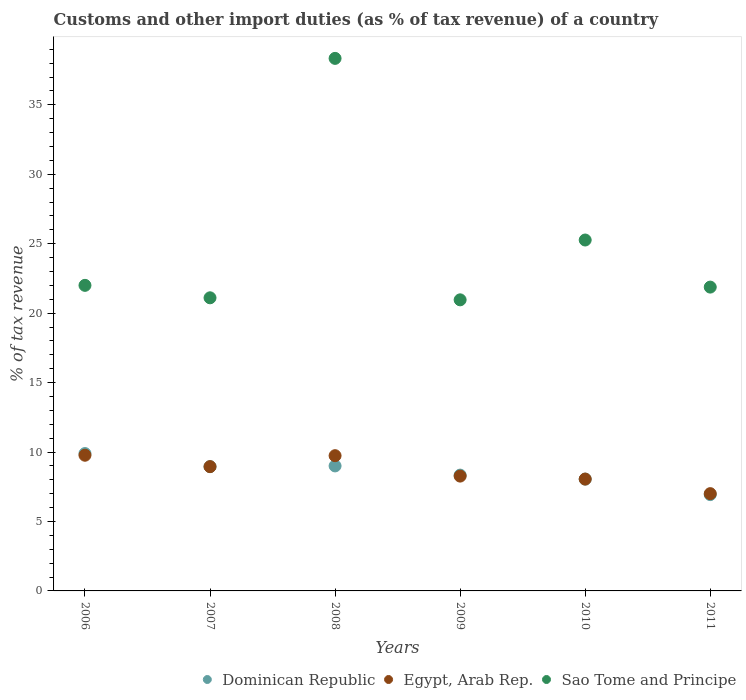Is the number of dotlines equal to the number of legend labels?
Provide a succinct answer. Yes. What is the percentage of tax revenue from customs in Sao Tome and Principe in 2010?
Provide a short and direct response. 25.27. Across all years, what is the maximum percentage of tax revenue from customs in Egypt, Arab Rep.?
Ensure brevity in your answer.  9.77. Across all years, what is the minimum percentage of tax revenue from customs in Sao Tome and Principe?
Your response must be concise. 20.96. In which year was the percentage of tax revenue from customs in Dominican Republic maximum?
Give a very brief answer. 2006. In which year was the percentage of tax revenue from customs in Dominican Republic minimum?
Ensure brevity in your answer.  2011. What is the total percentage of tax revenue from customs in Dominican Republic in the graph?
Keep it short and to the point. 51.17. What is the difference between the percentage of tax revenue from customs in Dominican Republic in 2006 and that in 2011?
Provide a succinct answer. 2.96. What is the difference between the percentage of tax revenue from customs in Egypt, Arab Rep. in 2008 and the percentage of tax revenue from customs in Dominican Republic in 2009?
Give a very brief answer. 1.4. What is the average percentage of tax revenue from customs in Sao Tome and Principe per year?
Your answer should be compact. 24.93. In the year 2009, what is the difference between the percentage of tax revenue from customs in Dominican Republic and percentage of tax revenue from customs in Egypt, Arab Rep.?
Offer a very short reply. 0.07. In how many years, is the percentage of tax revenue from customs in Egypt, Arab Rep. greater than 14 %?
Ensure brevity in your answer.  0. What is the ratio of the percentage of tax revenue from customs in Dominican Republic in 2009 to that in 2011?
Your response must be concise. 1.2. Is the percentage of tax revenue from customs in Dominican Republic in 2007 less than that in 2009?
Offer a very short reply. No. What is the difference between the highest and the second highest percentage of tax revenue from customs in Egypt, Arab Rep.?
Your response must be concise. 0.03. What is the difference between the highest and the lowest percentage of tax revenue from customs in Dominican Republic?
Provide a short and direct response. 2.96. In how many years, is the percentage of tax revenue from customs in Egypt, Arab Rep. greater than the average percentage of tax revenue from customs in Egypt, Arab Rep. taken over all years?
Your response must be concise. 3. Is the sum of the percentage of tax revenue from customs in Sao Tome and Principe in 2006 and 2007 greater than the maximum percentage of tax revenue from customs in Egypt, Arab Rep. across all years?
Give a very brief answer. Yes. Does the percentage of tax revenue from customs in Egypt, Arab Rep. monotonically increase over the years?
Offer a terse response. No. Is the percentage of tax revenue from customs in Sao Tome and Principe strictly greater than the percentage of tax revenue from customs in Dominican Republic over the years?
Provide a short and direct response. Yes. Is the percentage of tax revenue from customs in Sao Tome and Principe strictly less than the percentage of tax revenue from customs in Egypt, Arab Rep. over the years?
Make the answer very short. No. How many dotlines are there?
Provide a short and direct response. 3. How many years are there in the graph?
Provide a succinct answer. 6. Are the values on the major ticks of Y-axis written in scientific E-notation?
Your answer should be compact. No. Where does the legend appear in the graph?
Keep it short and to the point. Bottom right. What is the title of the graph?
Your answer should be very brief. Customs and other import duties (as % of tax revenue) of a country. Does "Cabo Verde" appear as one of the legend labels in the graph?
Offer a very short reply. No. What is the label or title of the X-axis?
Ensure brevity in your answer.  Years. What is the label or title of the Y-axis?
Offer a terse response. % of tax revenue. What is the % of tax revenue of Dominican Republic in 2006?
Provide a short and direct response. 9.89. What is the % of tax revenue of Egypt, Arab Rep. in 2006?
Your response must be concise. 9.77. What is the % of tax revenue in Sao Tome and Principe in 2006?
Provide a succinct answer. 22. What is the % of tax revenue of Dominican Republic in 2007?
Offer a terse response. 8.95. What is the % of tax revenue of Egypt, Arab Rep. in 2007?
Your response must be concise. 8.95. What is the % of tax revenue of Sao Tome and Principe in 2007?
Keep it short and to the point. 21.11. What is the % of tax revenue of Dominican Republic in 2008?
Ensure brevity in your answer.  9. What is the % of tax revenue in Egypt, Arab Rep. in 2008?
Provide a short and direct response. 9.74. What is the % of tax revenue in Sao Tome and Principe in 2008?
Provide a succinct answer. 38.35. What is the % of tax revenue in Dominican Republic in 2009?
Ensure brevity in your answer.  8.34. What is the % of tax revenue in Egypt, Arab Rep. in 2009?
Offer a terse response. 8.27. What is the % of tax revenue in Sao Tome and Principe in 2009?
Your answer should be compact. 20.96. What is the % of tax revenue in Dominican Republic in 2010?
Your answer should be compact. 8.05. What is the % of tax revenue in Egypt, Arab Rep. in 2010?
Offer a terse response. 8.05. What is the % of tax revenue in Sao Tome and Principe in 2010?
Your response must be concise. 25.27. What is the % of tax revenue in Dominican Republic in 2011?
Keep it short and to the point. 6.94. What is the % of tax revenue in Egypt, Arab Rep. in 2011?
Your answer should be very brief. 7.01. What is the % of tax revenue of Sao Tome and Principe in 2011?
Your response must be concise. 21.88. Across all years, what is the maximum % of tax revenue in Dominican Republic?
Ensure brevity in your answer.  9.89. Across all years, what is the maximum % of tax revenue in Egypt, Arab Rep.?
Your response must be concise. 9.77. Across all years, what is the maximum % of tax revenue in Sao Tome and Principe?
Your answer should be very brief. 38.35. Across all years, what is the minimum % of tax revenue of Dominican Republic?
Your answer should be very brief. 6.94. Across all years, what is the minimum % of tax revenue in Egypt, Arab Rep.?
Provide a short and direct response. 7.01. Across all years, what is the minimum % of tax revenue of Sao Tome and Principe?
Offer a very short reply. 20.96. What is the total % of tax revenue of Dominican Republic in the graph?
Make the answer very short. 51.17. What is the total % of tax revenue in Egypt, Arab Rep. in the graph?
Give a very brief answer. 51.79. What is the total % of tax revenue of Sao Tome and Principe in the graph?
Provide a succinct answer. 149.57. What is the difference between the % of tax revenue of Dominican Republic in 2006 and that in 2007?
Keep it short and to the point. 0.94. What is the difference between the % of tax revenue in Egypt, Arab Rep. in 2006 and that in 2007?
Your answer should be compact. 0.82. What is the difference between the % of tax revenue in Sao Tome and Principe in 2006 and that in 2007?
Your answer should be compact. 0.9. What is the difference between the % of tax revenue in Dominican Republic in 2006 and that in 2008?
Keep it short and to the point. 0.89. What is the difference between the % of tax revenue in Egypt, Arab Rep. in 2006 and that in 2008?
Your answer should be very brief. 0.03. What is the difference between the % of tax revenue in Sao Tome and Principe in 2006 and that in 2008?
Make the answer very short. -16.34. What is the difference between the % of tax revenue in Dominican Republic in 2006 and that in 2009?
Your answer should be very brief. 1.55. What is the difference between the % of tax revenue of Egypt, Arab Rep. in 2006 and that in 2009?
Provide a succinct answer. 1.5. What is the difference between the % of tax revenue in Sao Tome and Principe in 2006 and that in 2009?
Offer a very short reply. 1.04. What is the difference between the % of tax revenue of Dominican Republic in 2006 and that in 2010?
Give a very brief answer. 1.84. What is the difference between the % of tax revenue of Egypt, Arab Rep. in 2006 and that in 2010?
Keep it short and to the point. 1.72. What is the difference between the % of tax revenue of Sao Tome and Principe in 2006 and that in 2010?
Your answer should be very brief. -3.26. What is the difference between the % of tax revenue of Dominican Republic in 2006 and that in 2011?
Give a very brief answer. 2.96. What is the difference between the % of tax revenue of Egypt, Arab Rep. in 2006 and that in 2011?
Offer a very short reply. 2.77. What is the difference between the % of tax revenue in Sao Tome and Principe in 2006 and that in 2011?
Your answer should be compact. 0.13. What is the difference between the % of tax revenue in Dominican Republic in 2007 and that in 2008?
Provide a succinct answer. -0.05. What is the difference between the % of tax revenue of Egypt, Arab Rep. in 2007 and that in 2008?
Keep it short and to the point. -0.79. What is the difference between the % of tax revenue of Sao Tome and Principe in 2007 and that in 2008?
Keep it short and to the point. -17.24. What is the difference between the % of tax revenue of Dominican Republic in 2007 and that in 2009?
Ensure brevity in your answer.  0.61. What is the difference between the % of tax revenue in Egypt, Arab Rep. in 2007 and that in 2009?
Keep it short and to the point. 0.68. What is the difference between the % of tax revenue in Sao Tome and Principe in 2007 and that in 2009?
Offer a very short reply. 0.15. What is the difference between the % of tax revenue in Dominican Republic in 2007 and that in 2010?
Offer a terse response. 0.9. What is the difference between the % of tax revenue in Egypt, Arab Rep. in 2007 and that in 2010?
Provide a succinct answer. 0.9. What is the difference between the % of tax revenue of Sao Tome and Principe in 2007 and that in 2010?
Provide a short and direct response. -4.16. What is the difference between the % of tax revenue in Dominican Republic in 2007 and that in 2011?
Provide a short and direct response. 2.01. What is the difference between the % of tax revenue in Egypt, Arab Rep. in 2007 and that in 2011?
Your response must be concise. 1.95. What is the difference between the % of tax revenue in Sao Tome and Principe in 2007 and that in 2011?
Offer a very short reply. -0.77. What is the difference between the % of tax revenue in Dominican Republic in 2008 and that in 2009?
Provide a short and direct response. 0.66. What is the difference between the % of tax revenue in Egypt, Arab Rep. in 2008 and that in 2009?
Make the answer very short. 1.47. What is the difference between the % of tax revenue in Sao Tome and Principe in 2008 and that in 2009?
Provide a short and direct response. 17.39. What is the difference between the % of tax revenue in Dominican Republic in 2008 and that in 2010?
Provide a short and direct response. 0.95. What is the difference between the % of tax revenue in Egypt, Arab Rep. in 2008 and that in 2010?
Give a very brief answer. 1.68. What is the difference between the % of tax revenue in Sao Tome and Principe in 2008 and that in 2010?
Offer a very short reply. 13.08. What is the difference between the % of tax revenue in Dominican Republic in 2008 and that in 2011?
Provide a succinct answer. 2.07. What is the difference between the % of tax revenue of Egypt, Arab Rep. in 2008 and that in 2011?
Your answer should be very brief. 2.73. What is the difference between the % of tax revenue of Sao Tome and Principe in 2008 and that in 2011?
Offer a very short reply. 16.47. What is the difference between the % of tax revenue in Dominican Republic in 2009 and that in 2010?
Your response must be concise. 0.29. What is the difference between the % of tax revenue of Egypt, Arab Rep. in 2009 and that in 2010?
Give a very brief answer. 0.21. What is the difference between the % of tax revenue in Sao Tome and Principe in 2009 and that in 2010?
Your response must be concise. -4.31. What is the difference between the % of tax revenue in Dominican Republic in 2009 and that in 2011?
Make the answer very short. 1.4. What is the difference between the % of tax revenue in Egypt, Arab Rep. in 2009 and that in 2011?
Provide a short and direct response. 1.26. What is the difference between the % of tax revenue in Sao Tome and Principe in 2009 and that in 2011?
Offer a very short reply. -0.92. What is the difference between the % of tax revenue in Dominican Republic in 2010 and that in 2011?
Your response must be concise. 1.12. What is the difference between the % of tax revenue in Egypt, Arab Rep. in 2010 and that in 2011?
Ensure brevity in your answer.  1.05. What is the difference between the % of tax revenue of Sao Tome and Principe in 2010 and that in 2011?
Make the answer very short. 3.39. What is the difference between the % of tax revenue of Dominican Republic in 2006 and the % of tax revenue of Egypt, Arab Rep. in 2007?
Offer a terse response. 0.94. What is the difference between the % of tax revenue in Dominican Republic in 2006 and the % of tax revenue in Sao Tome and Principe in 2007?
Provide a succinct answer. -11.22. What is the difference between the % of tax revenue of Egypt, Arab Rep. in 2006 and the % of tax revenue of Sao Tome and Principe in 2007?
Give a very brief answer. -11.34. What is the difference between the % of tax revenue of Dominican Republic in 2006 and the % of tax revenue of Egypt, Arab Rep. in 2008?
Make the answer very short. 0.15. What is the difference between the % of tax revenue in Dominican Republic in 2006 and the % of tax revenue in Sao Tome and Principe in 2008?
Ensure brevity in your answer.  -28.46. What is the difference between the % of tax revenue in Egypt, Arab Rep. in 2006 and the % of tax revenue in Sao Tome and Principe in 2008?
Make the answer very short. -28.58. What is the difference between the % of tax revenue in Dominican Republic in 2006 and the % of tax revenue in Egypt, Arab Rep. in 2009?
Your response must be concise. 1.62. What is the difference between the % of tax revenue of Dominican Republic in 2006 and the % of tax revenue of Sao Tome and Principe in 2009?
Ensure brevity in your answer.  -11.07. What is the difference between the % of tax revenue in Egypt, Arab Rep. in 2006 and the % of tax revenue in Sao Tome and Principe in 2009?
Ensure brevity in your answer.  -11.19. What is the difference between the % of tax revenue of Dominican Republic in 2006 and the % of tax revenue of Egypt, Arab Rep. in 2010?
Make the answer very short. 1.84. What is the difference between the % of tax revenue of Dominican Republic in 2006 and the % of tax revenue of Sao Tome and Principe in 2010?
Provide a succinct answer. -15.38. What is the difference between the % of tax revenue of Egypt, Arab Rep. in 2006 and the % of tax revenue of Sao Tome and Principe in 2010?
Your response must be concise. -15.5. What is the difference between the % of tax revenue in Dominican Republic in 2006 and the % of tax revenue in Egypt, Arab Rep. in 2011?
Offer a very short reply. 2.89. What is the difference between the % of tax revenue in Dominican Republic in 2006 and the % of tax revenue in Sao Tome and Principe in 2011?
Offer a very short reply. -11.99. What is the difference between the % of tax revenue of Egypt, Arab Rep. in 2006 and the % of tax revenue of Sao Tome and Principe in 2011?
Give a very brief answer. -12.11. What is the difference between the % of tax revenue in Dominican Republic in 2007 and the % of tax revenue in Egypt, Arab Rep. in 2008?
Your response must be concise. -0.79. What is the difference between the % of tax revenue of Dominican Republic in 2007 and the % of tax revenue of Sao Tome and Principe in 2008?
Keep it short and to the point. -29.4. What is the difference between the % of tax revenue of Egypt, Arab Rep. in 2007 and the % of tax revenue of Sao Tome and Principe in 2008?
Your answer should be very brief. -29.4. What is the difference between the % of tax revenue in Dominican Republic in 2007 and the % of tax revenue in Egypt, Arab Rep. in 2009?
Your response must be concise. 0.68. What is the difference between the % of tax revenue in Dominican Republic in 2007 and the % of tax revenue in Sao Tome and Principe in 2009?
Offer a very short reply. -12.01. What is the difference between the % of tax revenue in Egypt, Arab Rep. in 2007 and the % of tax revenue in Sao Tome and Principe in 2009?
Make the answer very short. -12.01. What is the difference between the % of tax revenue of Dominican Republic in 2007 and the % of tax revenue of Egypt, Arab Rep. in 2010?
Keep it short and to the point. 0.89. What is the difference between the % of tax revenue in Dominican Republic in 2007 and the % of tax revenue in Sao Tome and Principe in 2010?
Your answer should be very brief. -16.32. What is the difference between the % of tax revenue of Egypt, Arab Rep. in 2007 and the % of tax revenue of Sao Tome and Principe in 2010?
Ensure brevity in your answer.  -16.32. What is the difference between the % of tax revenue in Dominican Republic in 2007 and the % of tax revenue in Egypt, Arab Rep. in 2011?
Give a very brief answer. 1.94. What is the difference between the % of tax revenue of Dominican Republic in 2007 and the % of tax revenue of Sao Tome and Principe in 2011?
Offer a terse response. -12.93. What is the difference between the % of tax revenue in Egypt, Arab Rep. in 2007 and the % of tax revenue in Sao Tome and Principe in 2011?
Your answer should be compact. -12.93. What is the difference between the % of tax revenue of Dominican Republic in 2008 and the % of tax revenue of Egypt, Arab Rep. in 2009?
Ensure brevity in your answer.  0.73. What is the difference between the % of tax revenue of Dominican Republic in 2008 and the % of tax revenue of Sao Tome and Principe in 2009?
Keep it short and to the point. -11.96. What is the difference between the % of tax revenue of Egypt, Arab Rep. in 2008 and the % of tax revenue of Sao Tome and Principe in 2009?
Provide a succinct answer. -11.22. What is the difference between the % of tax revenue of Dominican Republic in 2008 and the % of tax revenue of Egypt, Arab Rep. in 2010?
Your answer should be very brief. 0.95. What is the difference between the % of tax revenue of Dominican Republic in 2008 and the % of tax revenue of Sao Tome and Principe in 2010?
Ensure brevity in your answer.  -16.27. What is the difference between the % of tax revenue of Egypt, Arab Rep. in 2008 and the % of tax revenue of Sao Tome and Principe in 2010?
Keep it short and to the point. -15.53. What is the difference between the % of tax revenue in Dominican Republic in 2008 and the % of tax revenue in Egypt, Arab Rep. in 2011?
Your answer should be very brief. 2. What is the difference between the % of tax revenue in Dominican Republic in 2008 and the % of tax revenue in Sao Tome and Principe in 2011?
Ensure brevity in your answer.  -12.88. What is the difference between the % of tax revenue in Egypt, Arab Rep. in 2008 and the % of tax revenue in Sao Tome and Principe in 2011?
Keep it short and to the point. -12.14. What is the difference between the % of tax revenue in Dominican Republic in 2009 and the % of tax revenue in Egypt, Arab Rep. in 2010?
Provide a succinct answer. 0.28. What is the difference between the % of tax revenue in Dominican Republic in 2009 and the % of tax revenue in Sao Tome and Principe in 2010?
Your answer should be compact. -16.93. What is the difference between the % of tax revenue in Egypt, Arab Rep. in 2009 and the % of tax revenue in Sao Tome and Principe in 2010?
Offer a very short reply. -17. What is the difference between the % of tax revenue in Dominican Republic in 2009 and the % of tax revenue in Egypt, Arab Rep. in 2011?
Make the answer very short. 1.33. What is the difference between the % of tax revenue in Dominican Republic in 2009 and the % of tax revenue in Sao Tome and Principe in 2011?
Make the answer very short. -13.54. What is the difference between the % of tax revenue of Egypt, Arab Rep. in 2009 and the % of tax revenue of Sao Tome and Principe in 2011?
Your answer should be very brief. -13.61. What is the difference between the % of tax revenue in Dominican Republic in 2010 and the % of tax revenue in Egypt, Arab Rep. in 2011?
Offer a very short reply. 1.05. What is the difference between the % of tax revenue of Dominican Republic in 2010 and the % of tax revenue of Sao Tome and Principe in 2011?
Offer a very short reply. -13.83. What is the difference between the % of tax revenue of Egypt, Arab Rep. in 2010 and the % of tax revenue of Sao Tome and Principe in 2011?
Your answer should be very brief. -13.82. What is the average % of tax revenue in Dominican Republic per year?
Provide a succinct answer. 8.53. What is the average % of tax revenue in Egypt, Arab Rep. per year?
Provide a short and direct response. 8.63. What is the average % of tax revenue of Sao Tome and Principe per year?
Provide a short and direct response. 24.93. In the year 2006, what is the difference between the % of tax revenue of Dominican Republic and % of tax revenue of Egypt, Arab Rep.?
Offer a very short reply. 0.12. In the year 2006, what is the difference between the % of tax revenue in Dominican Republic and % of tax revenue in Sao Tome and Principe?
Offer a terse response. -12.11. In the year 2006, what is the difference between the % of tax revenue in Egypt, Arab Rep. and % of tax revenue in Sao Tome and Principe?
Ensure brevity in your answer.  -12.23. In the year 2007, what is the difference between the % of tax revenue of Dominican Republic and % of tax revenue of Egypt, Arab Rep.?
Offer a terse response. -0. In the year 2007, what is the difference between the % of tax revenue of Dominican Republic and % of tax revenue of Sao Tome and Principe?
Give a very brief answer. -12.16. In the year 2007, what is the difference between the % of tax revenue in Egypt, Arab Rep. and % of tax revenue in Sao Tome and Principe?
Your response must be concise. -12.16. In the year 2008, what is the difference between the % of tax revenue of Dominican Republic and % of tax revenue of Egypt, Arab Rep.?
Ensure brevity in your answer.  -0.74. In the year 2008, what is the difference between the % of tax revenue in Dominican Republic and % of tax revenue in Sao Tome and Principe?
Provide a short and direct response. -29.35. In the year 2008, what is the difference between the % of tax revenue of Egypt, Arab Rep. and % of tax revenue of Sao Tome and Principe?
Your answer should be compact. -28.61. In the year 2009, what is the difference between the % of tax revenue of Dominican Republic and % of tax revenue of Egypt, Arab Rep.?
Give a very brief answer. 0.07. In the year 2009, what is the difference between the % of tax revenue of Dominican Republic and % of tax revenue of Sao Tome and Principe?
Your response must be concise. -12.62. In the year 2009, what is the difference between the % of tax revenue in Egypt, Arab Rep. and % of tax revenue in Sao Tome and Principe?
Ensure brevity in your answer.  -12.69. In the year 2010, what is the difference between the % of tax revenue of Dominican Republic and % of tax revenue of Egypt, Arab Rep.?
Make the answer very short. -0. In the year 2010, what is the difference between the % of tax revenue in Dominican Republic and % of tax revenue in Sao Tome and Principe?
Offer a very short reply. -17.22. In the year 2010, what is the difference between the % of tax revenue in Egypt, Arab Rep. and % of tax revenue in Sao Tome and Principe?
Provide a succinct answer. -17.21. In the year 2011, what is the difference between the % of tax revenue in Dominican Republic and % of tax revenue in Egypt, Arab Rep.?
Provide a succinct answer. -0.07. In the year 2011, what is the difference between the % of tax revenue in Dominican Republic and % of tax revenue in Sao Tome and Principe?
Keep it short and to the point. -14.94. In the year 2011, what is the difference between the % of tax revenue of Egypt, Arab Rep. and % of tax revenue of Sao Tome and Principe?
Your answer should be very brief. -14.87. What is the ratio of the % of tax revenue of Dominican Republic in 2006 to that in 2007?
Offer a very short reply. 1.11. What is the ratio of the % of tax revenue in Egypt, Arab Rep. in 2006 to that in 2007?
Make the answer very short. 1.09. What is the ratio of the % of tax revenue in Sao Tome and Principe in 2006 to that in 2007?
Your response must be concise. 1.04. What is the ratio of the % of tax revenue in Dominican Republic in 2006 to that in 2008?
Keep it short and to the point. 1.1. What is the ratio of the % of tax revenue of Egypt, Arab Rep. in 2006 to that in 2008?
Ensure brevity in your answer.  1. What is the ratio of the % of tax revenue in Sao Tome and Principe in 2006 to that in 2008?
Offer a very short reply. 0.57. What is the ratio of the % of tax revenue of Dominican Republic in 2006 to that in 2009?
Provide a short and direct response. 1.19. What is the ratio of the % of tax revenue in Egypt, Arab Rep. in 2006 to that in 2009?
Keep it short and to the point. 1.18. What is the ratio of the % of tax revenue of Sao Tome and Principe in 2006 to that in 2009?
Offer a very short reply. 1.05. What is the ratio of the % of tax revenue of Dominican Republic in 2006 to that in 2010?
Provide a succinct answer. 1.23. What is the ratio of the % of tax revenue of Egypt, Arab Rep. in 2006 to that in 2010?
Keep it short and to the point. 1.21. What is the ratio of the % of tax revenue in Sao Tome and Principe in 2006 to that in 2010?
Make the answer very short. 0.87. What is the ratio of the % of tax revenue in Dominican Republic in 2006 to that in 2011?
Offer a terse response. 1.43. What is the ratio of the % of tax revenue in Egypt, Arab Rep. in 2006 to that in 2011?
Offer a terse response. 1.39. What is the ratio of the % of tax revenue of Egypt, Arab Rep. in 2007 to that in 2008?
Offer a terse response. 0.92. What is the ratio of the % of tax revenue in Sao Tome and Principe in 2007 to that in 2008?
Your answer should be very brief. 0.55. What is the ratio of the % of tax revenue in Dominican Republic in 2007 to that in 2009?
Offer a terse response. 1.07. What is the ratio of the % of tax revenue of Egypt, Arab Rep. in 2007 to that in 2009?
Ensure brevity in your answer.  1.08. What is the ratio of the % of tax revenue in Dominican Republic in 2007 to that in 2010?
Offer a very short reply. 1.11. What is the ratio of the % of tax revenue in Egypt, Arab Rep. in 2007 to that in 2010?
Provide a short and direct response. 1.11. What is the ratio of the % of tax revenue in Sao Tome and Principe in 2007 to that in 2010?
Give a very brief answer. 0.84. What is the ratio of the % of tax revenue in Dominican Republic in 2007 to that in 2011?
Offer a very short reply. 1.29. What is the ratio of the % of tax revenue of Egypt, Arab Rep. in 2007 to that in 2011?
Ensure brevity in your answer.  1.28. What is the ratio of the % of tax revenue of Sao Tome and Principe in 2007 to that in 2011?
Your answer should be compact. 0.96. What is the ratio of the % of tax revenue in Dominican Republic in 2008 to that in 2009?
Your answer should be compact. 1.08. What is the ratio of the % of tax revenue in Egypt, Arab Rep. in 2008 to that in 2009?
Provide a short and direct response. 1.18. What is the ratio of the % of tax revenue of Sao Tome and Principe in 2008 to that in 2009?
Keep it short and to the point. 1.83. What is the ratio of the % of tax revenue in Dominican Republic in 2008 to that in 2010?
Offer a very short reply. 1.12. What is the ratio of the % of tax revenue in Egypt, Arab Rep. in 2008 to that in 2010?
Your answer should be very brief. 1.21. What is the ratio of the % of tax revenue of Sao Tome and Principe in 2008 to that in 2010?
Offer a very short reply. 1.52. What is the ratio of the % of tax revenue in Dominican Republic in 2008 to that in 2011?
Provide a short and direct response. 1.3. What is the ratio of the % of tax revenue of Egypt, Arab Rep. in 2008 to that in 2011?
Offer a terse response. 1.39. What is the ratio of the % of tax revenue of Sao Tome and Principe in 2008 to that in 2011?
Your answer should be compact. 1.75. What is the ratio of the % of tax revenue of Dominican Republic in 2009 to that in 2010?
Provide a succinct answer. 1.04. What is the ratio of the % of tax revenue of Egypt, Arab Rep. in 2009 to that in 2010?
Give a very brief answer. 1.03. What is the ratio of the % of tax revenue of Sao Tome and Principe in 2009 to that in 2010?
Provide a succinct answer. 0.83. What is the ratio of the % of tax revenue in Dominican Republic in 2009 to that in 2011?
Your response must be concise. 1.2. What is the ratio of the % of tax revenue in Egypt, Arab Rep. in 2009 to that in 2011?
Give a very brief answer. 1.18. What is the ratio of the % of tax revenue of Sao Tome and Principe in 2009 to that in 2011?
Give a very brief answer. 0.96. What is the ratio of the % of tax revenue in Dominican Republic in 2010 to that in 2011?
Make the answer very short. 1.16. What is the ratio of the % of tax revenue of Egypt, Arab Rep. in 2010 to that in 2011?
Your answer should be compact. 1.15. What is the ratio of the % of tax revenue of Sao Tome and Principe in 2010 to that in 2011?
Offer a very short reply. 1.16. What is the difference between the highest and the second highest % of tax revenue of Dominican Republic?
Give a very brief answer. 0.89. What is the difference between the highest and the second highest % of tax revenue of Egypt, Arab Rep.?
Give a very brief answer. 0.03. What is the difference between the highest and the second highest % of tax revenue in Sao Tome and Principe?
Provide a short and direct response. 13.08. What is the difference between the highest and the lowest % of tax revenue of Dominican Republic?
Provide a succinct answer. 2.96. What is the difference between the highest and the lowest % of tax revenue in Egypt, Arab Rep.?
Give a very brief answer. 2.77. What is the difference between the highest and the lowest % of tax revenue in Sao Tome and Principe?
Provide a short and direct response. 17.39. 